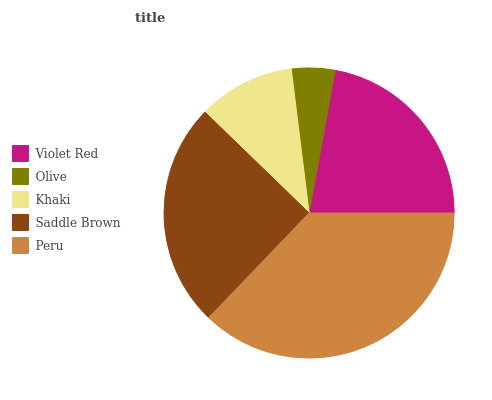Is Olive the minimum?
Answer yes or no. Yes. Is Peru the maximum?
Answer yes or no. Yes. Is Khaki the minimum?
Answer yes or no. No. Is Khaki the maximum?
Answer yes or no. No. Is Khaki greater than Olive?
Answer yes or no. Yes. Is Olive less than Khaki?
Answer yes or no. Yes. Is Olive greater than Khaki?
Answer yes or no. No. Is Khaki less than Olive?
Answer yes or no. No. Is Violet Red the high median?
Answer yes or no. Yes. Is Violet Red the low median?
Answer yes or no. Yes. Is Peru the high median?
Answer yes or no. No. Is Khaki the low median?
Answer yes or no. No. 